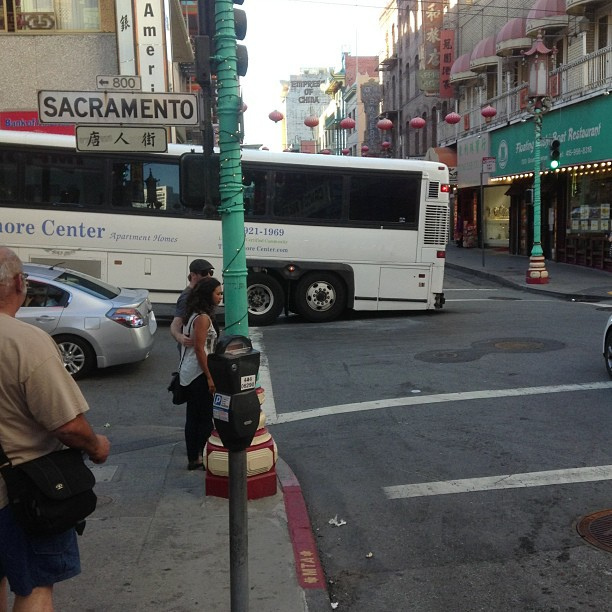Read all the text in this image. MTA 446 Center Rrestarant Apartment ore SACRAMENTO 800 Ameri 